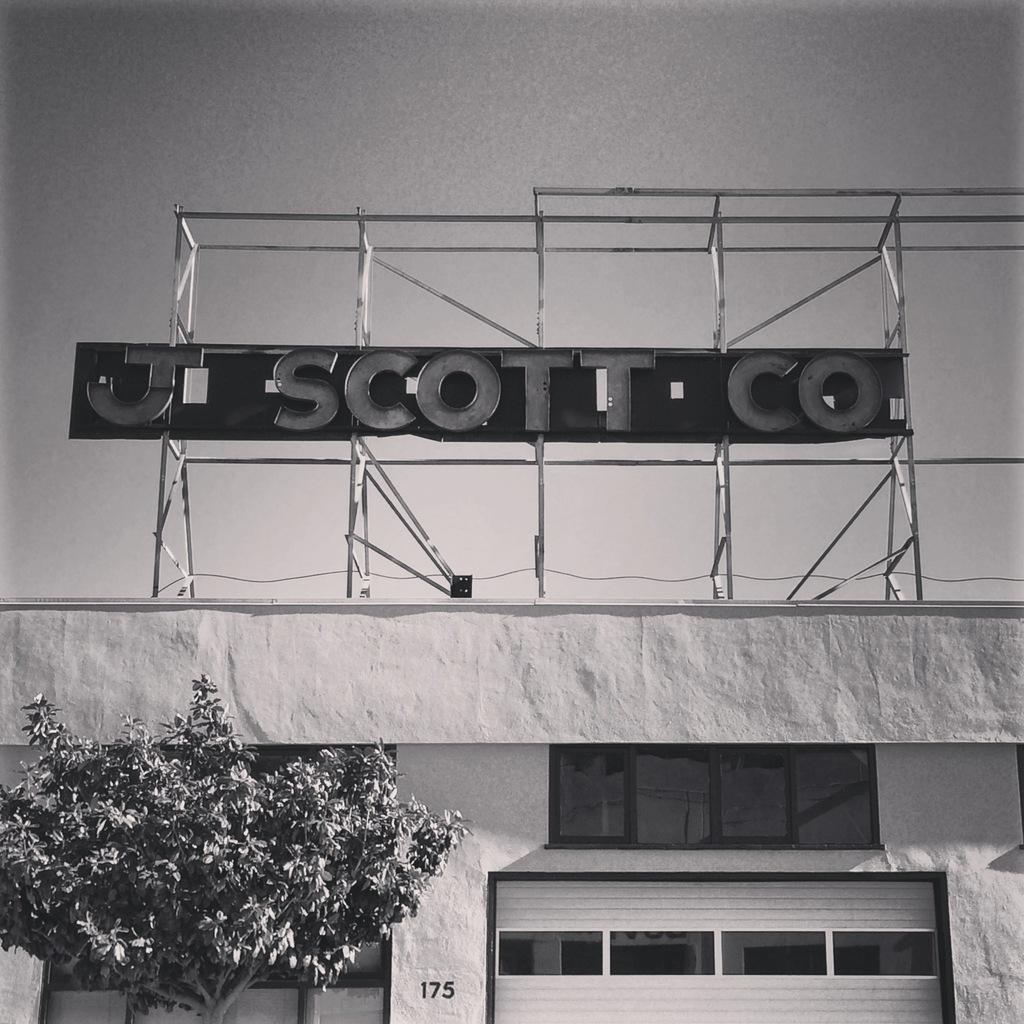Is this a hotel or a business?
Give a very brief answer. Business. What is it called?
Keep it short and to the point. J scott co. 